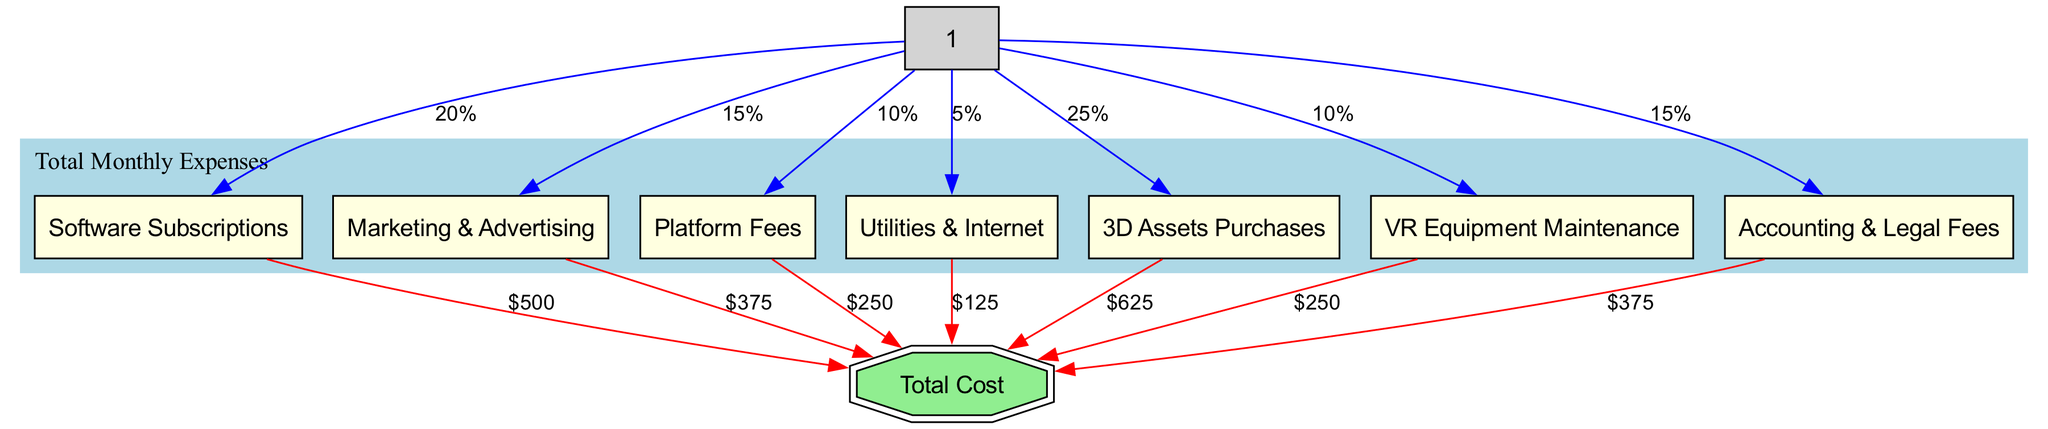What percentage of total monthly expenses is allocated to software subscriptions? The diagram indicates that software subscriptions are connected to total monthly expenses with a label of "20%". This label directly shows the percentage allocation for software subscriptions.
Answer: 20% What is the monetary value of platform fees? The monetary value for platform fees is represented in the diagram as "$250". This is shown as an edge connecting platform fees to total cost.
Answer: $250 How many total expense categories are shown in the diagram? By counting the nodes under the total monthly expenses, we find eight expense categories in addition to the total. The relevant nodes are software subscriptions, marketing & advertising, platform fees, utilities & internet, 3D assets purchases, VR equipment maintenance, and accounting & legal fees.
Answer: 8 What is the total amount dedicated to 3D assets purchases? Looking at the edge that connects 3D assets purchases to total cost, the diagram specifies a monetary value of "$625". This indicates the total amount for that category.
Answer: $625 Which expense category has the lowest percentage allocation? By examining the percentages next to each expense category, we find that utilities & internet is allocated "5%", which is the lowest percentage among the listed categories.
Answer: 5% What are the combined costs of marketing & advertising and accounting & legal fees? To find this, we look at the individual costs represented in the diagram: marketing & advertising is "$375" and accounting & legal fees is "$375". Summing these values gives us a total of $375 + $375 = $750. Therefore, the combined cost is "$750".
Answer: $750 What is the total value of monthly expenses? The total monthly expenses node connects to total cost, which aggregates all the individual costs. To find this, we can add all individual costs provided on each connection, yielding a total cost calculation of $500 + $375 + $250 + $125 + $625 + $250 + $375, which totals "$2500".
Answer: $2500 Which two categories have the same percentage allocation? Upon reviewing the percentages indicated, we see that both VR equipment maintenance and platform fees are allocated "10%".
Answer: 10% 